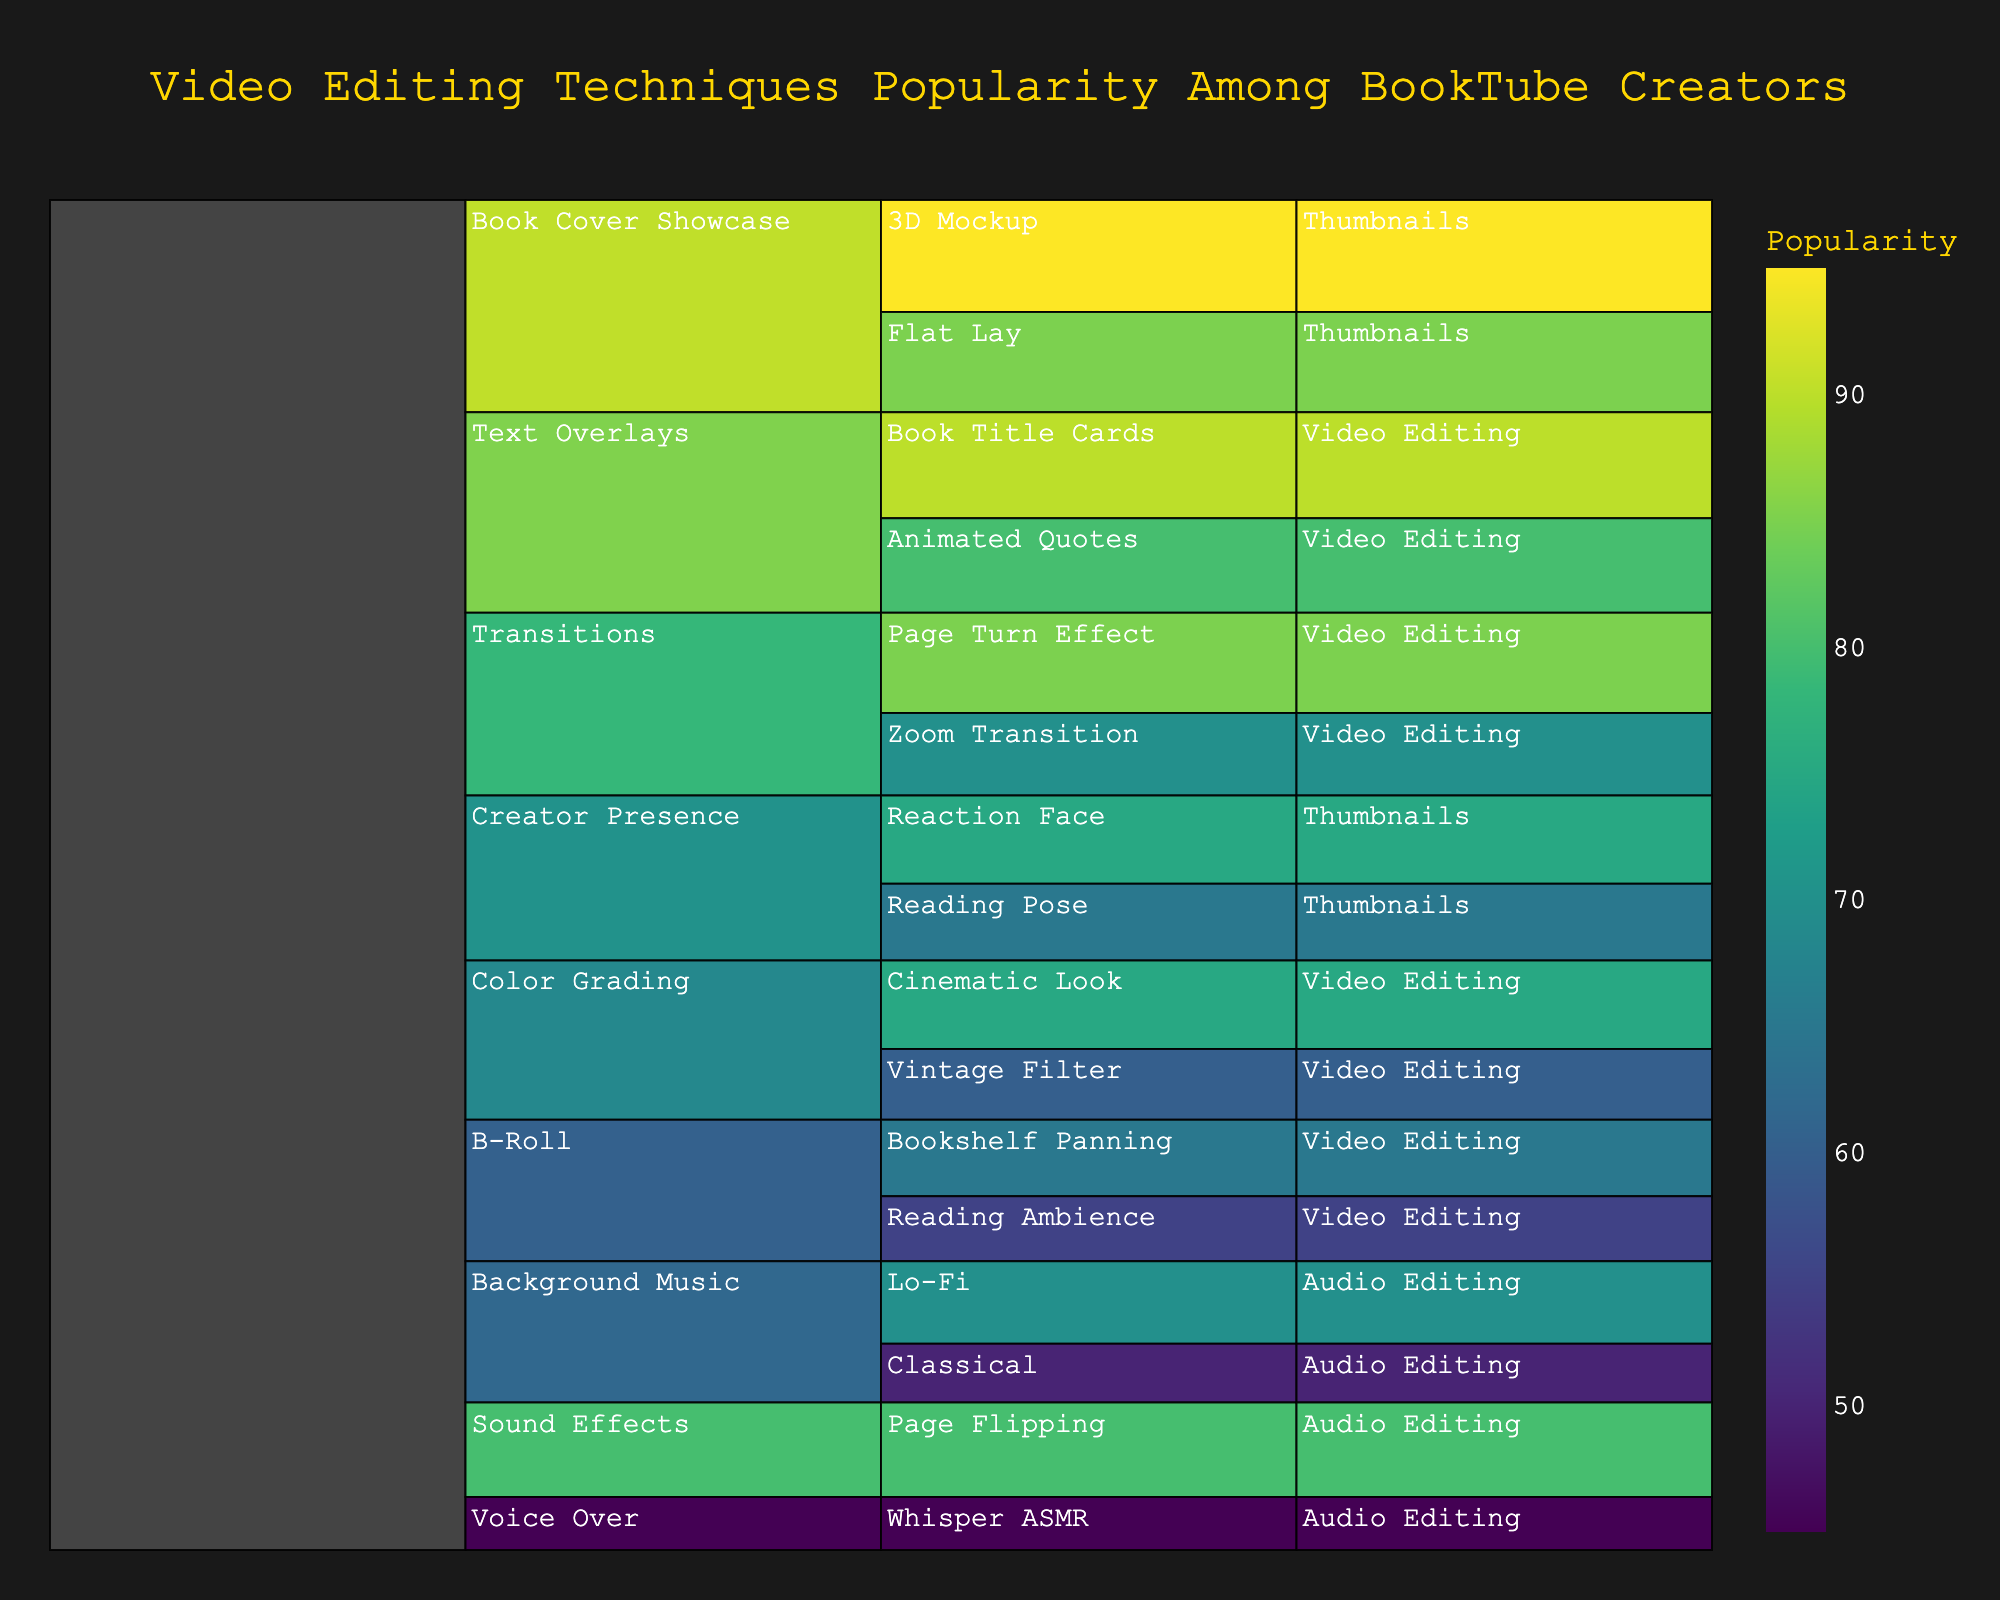What is the most popular video editing technique among BookTube creators? The most popular video editing technique can be identified by looking for the highest value in the "Popularity" metric among all techniques listed in the icicle chart. The technique with the highest value is "3D Mockup" under the "Book Cover Showcase" subcategory within the "Thumbnails" category, with a popularity rating of 95.
Answer: 3D Mockup How does the popularity of Lo-Fi background music compare with Classical background music? To compare the popularity of Lo-Fi background music and Classical background music, check their respective popularity values. Lo-Fi has a value of 70, while Classical has a value of 50. Therefore, Lo-Fi is more popular.
Answer: Lo-Fi is more popular What is the average popularity of color grading techniques? The average popularity of color grading techniques is calculated by taking the sum of the popularity values and dividing by the number of techniques. The ratings are 75 and 60 for "Cinematic Look" and "Vintage Filter" respectively. (75 + 60) / 2 = 67.5
Answer: 67.5 Which text overlay technique is more popular, Animated Quotes or Book Title Cards? By comparing the popularity values of the two text overlay techniques, we see that Animated Quotes has a popularity of 80, while Book Title Cards has a popularity of 90. Therefore, Book Title Cards is more popular.
Answer: Book Title Cards What is the least popular video editing technique within the 'Audio Editing' category? Look at the techniques under the 'Audio Editing' category and identify the one with the lowest popularity value. The 'Whisper ASMR' technique within the 'Voice Over' subcategory has the lowest popularity value of 45.
Answer: Whisper ASMR What is the combined popularity of the page turn effect and zoom transition? To find the combined popularity, add the popularity values of the page turn effect and the zoom transition. Page Turn Effect has a popularity of 85 and Zoom Transition has a popularity of 70. So, 85 + 70 = 155
Answer: 155 How many subcategories exist under the 'Thumbnails' category? The number of subcategories under the 'Thumbnails' category can be found by counting the distinct subcategories in that section. There are two: 'Book Cover Showcase' and 'Creator Presence'.
Answer: 2 Which B-roll technique is more popular: Bookshelf Panning or Reading Ambience? By comparing the popularity values, Bookshelf Panning has a popularity of 65, while Reading Ambience has a popularity of 55. Therefore, Bookshelf Panning is more popular.
Answer: Bookshelf Panning What is the total popularity value of all editing techniques within 'Video Editing'? Add the popularity values of all techniques under 'Video Editing': 75 (Cinematic Look) + 60 (Vintage Filter) + 85 (Page Turn Effect) + 70 (Zoom Transition) + 80 (Animated Quotes) + 90 (Book Title Cards) + 65 (Bookshelf Panning) + 55 (Reading Ambience). Sum = 580.
Answer: 580 